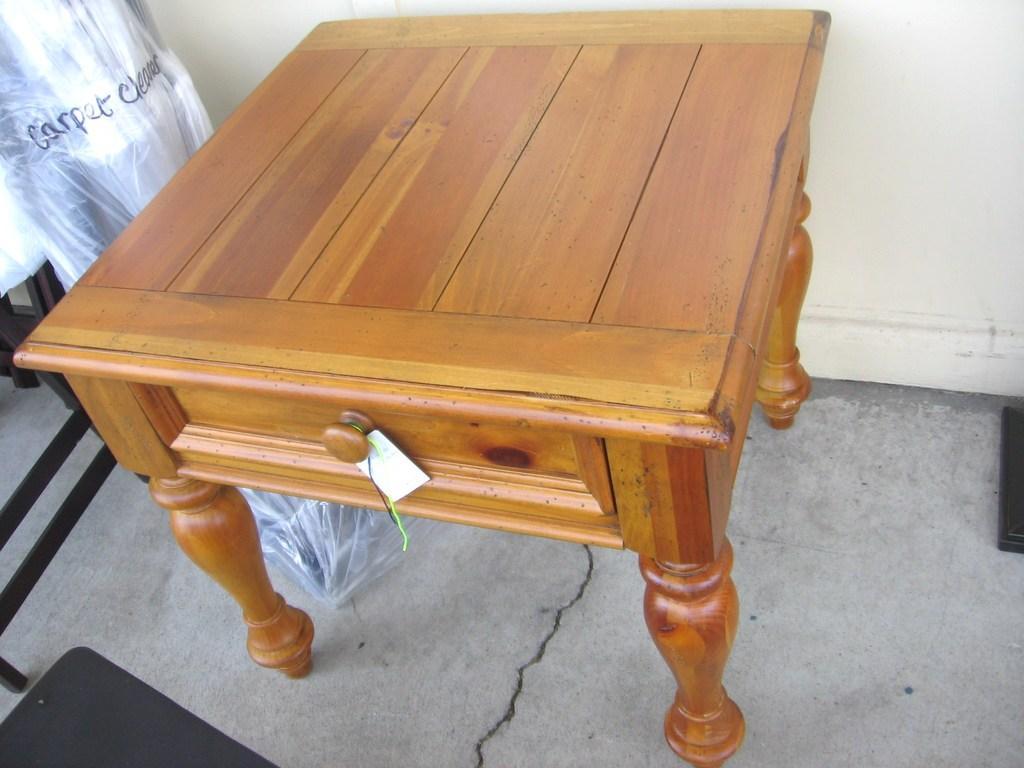Can you describe this image briefly? In the image there is a table with a tag. Beside that there is an object covered with a cover. And at the bottom of the image there is a black color object. 